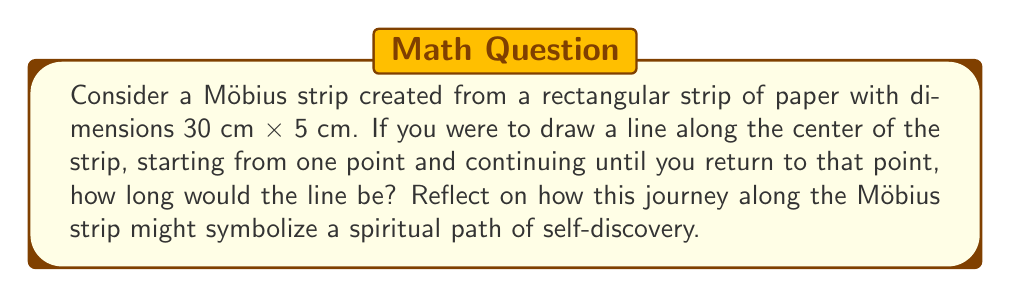Could you help me with this problem? To solve this problem, let's break it down into steps:

1) First, we need to understand the properties of a Möbius strip. A Möbius strip is a surface with only one side and one edge. When you trace a line along the center of a Möbius strip, you'll travel along both "sides" of the original strip before returning to the starting point.

2) The length of the center line will be equal to the length of the original strip. This is because the line goes once around the entire length of the strip.

3) In this case, the length of the original strip is 30 cm.

4) However, there's a deeper meaning to consider. The journey along a Möbius strip is continuous and returns to its starting point, much like many spiritual journeys. You end up where you began, but with a new perspective, having traversed what seemed to be both sides of the strip.

5) Mathematically, we can represent this journey as:

   $$L = l$$

   Where $L$ is the length of the center line, and $l$ is the length of the original strip.

[asy]
size(200,100);
path p = (0,0)..(50,20)..(100,0)..(50,-20)..cycle;
draw(p);
draw((0,0)--(100,0),dashed);
label("30 cm",(-5,10));
label("5 cm",(105,10));
[/asy]

This diagram represents a simplified view of a Möbius strip, with the dashed line indicating the center line that forms a complete loop.
Answer: The line along the center of the Möbius strip would be 30 cm long. 